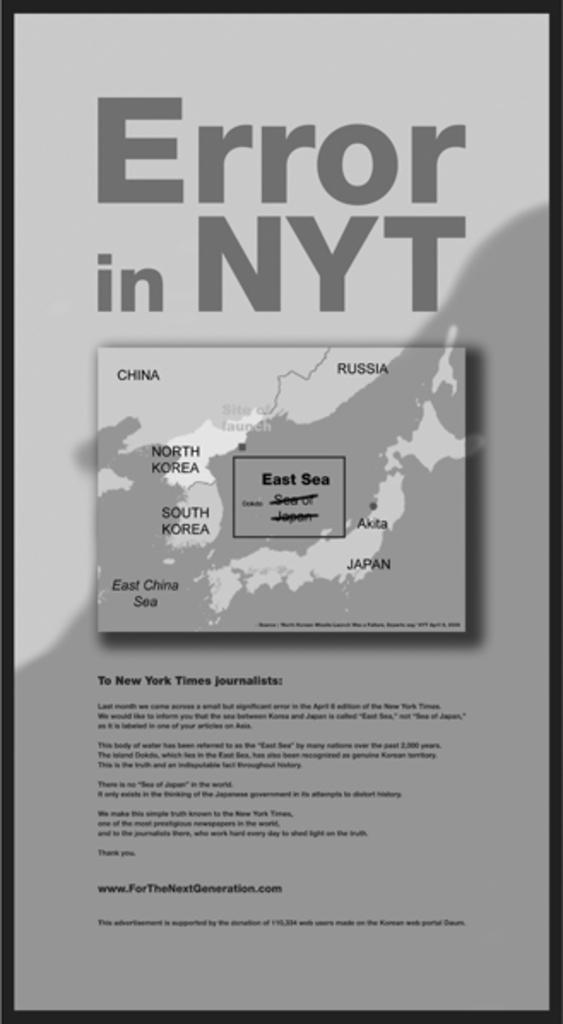In one or two sentences, can you explain what this image depicts? In this picture there is an object on which we can see the text is written and we can see the map on the object. 